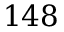<formula> <loc_0><loc_0><loc_500><loc_500>1 4 8</formula> 